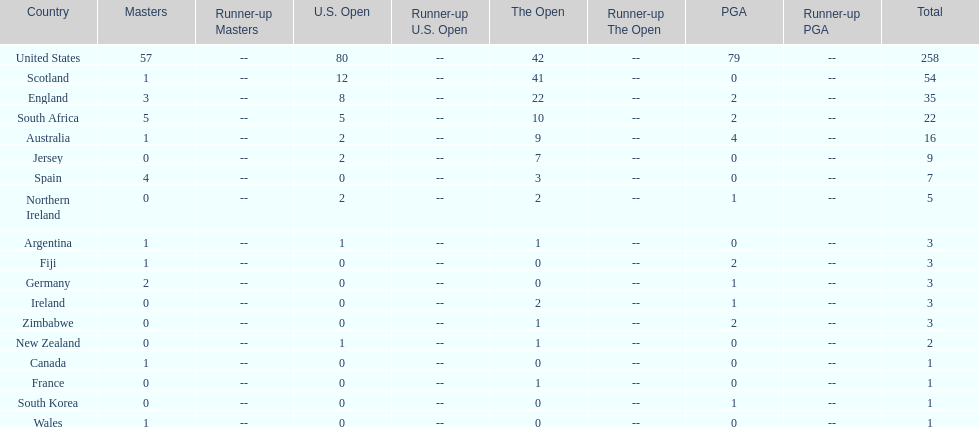I'm looking to parse the entire table for insights. Could you assist me with that? {'header': ['Country', 'Masters', 'Runner-up Masters', 'U.S. Open', 'Runner-up U.S. Open', 'The Open', 'Runner-up The Open', 'PGA', 'Runner-up PGA', 'Total'], 'rows': [['United States', '57', '--', '80', '--', '42', '--', '79', '--', '258'], ['Scotland', '1', '--', '12', '--', '41', '--', '0', '--', '54'], ['England', '3', '--', '8', '--', '22', '--', '2', '--', '35'], ['South Africa', '5', '--', '5', '--', '10', '--', '2', '--', '22'], ['Australia', '1', '--', '2', '--', '9', '--', '4', '--', '16'], ['Jersey', '0', '--', '2', '--', '7', '--', '0', '--', '9'], ['Spain', '4', '--', '0', '--', '3', '--', '0', '--', '7'], ['Northern Ireland', '0', '--', '2', '--', '2', '--', '1', '--', '5'], ['Argentina', '1', '--', '1', '--', '1', '--', '0', '--', '3'], ['Fiji', '1', '--', '0', '--', '0', '--', '2', '--', '3'], ['Germany', '2', '--', '0', '--', '0', '--', '1', '--', '3'], ['Ireland', '0', '--', '0', '--', '2', '--', '1', '--', '3'], ['Zimbabwe', '0', '--', '0', '--', '1', '--', '2', '--', '3'], ['New Zealand', '0', '--', '1', '--', '1', '--', '0', '--', '2'], ['Canada', '1', '--', '0', '--', '0', '--', '0', '--', '1'], ['France', '0', '--', '0', '--', '1', '--', '0', '--', '1'], ['South Korea', '0', '--', '0', '--', '0', '--', '1', '--', '1'], ['Wales', '1', '--', '0', '--', '0', '--', '0', '--', '1']]} What is the overall count of spain's championships? 7. 